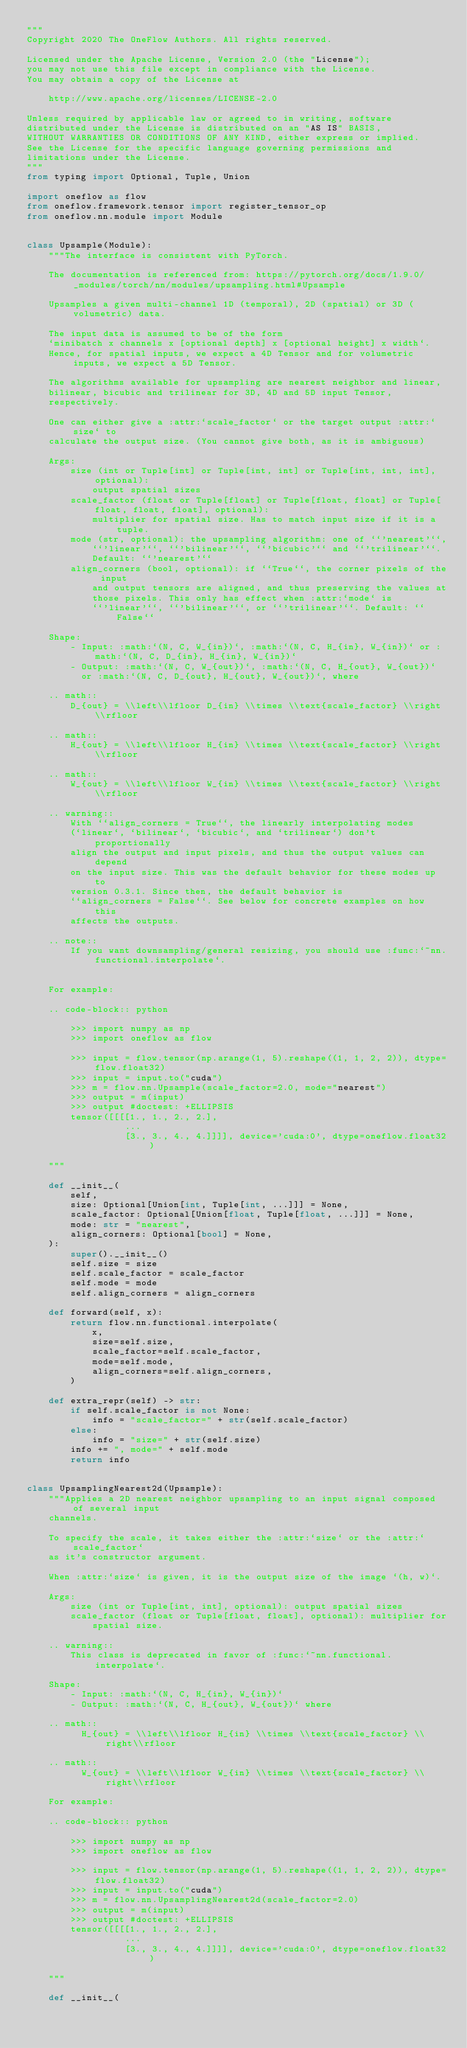Convert code to text. <code><loc_0><loc_0><loc_500><loc_500><_Python_>"""
Copyright 2020 The OneFlow Authors. All rights reserved.

Licensed under the Apache License, Version 2.0 (the "License");
you may not use this file except in compliance with the License.
You may obtain a copy of the License at

    http://www.apache.org/licenses/LICENSE-2.0

Unless required by applicable law or agreed to in writing, software
distributed under the License is distributed on an "AS IS" BASIS,
WITHOUT WARRANTIES OR CONDITIONS OF ANY KIND, either express or implied.
See the License for the specific language governing permissions and
limitations under the License.
"""
from typing import Optional, Tuple, Union

import oneflow as flow
from oneflow.framework.tensor import register_tensor_op
from oneflow.nn.module import Module


class Upsample(Module):
    """The interface is consistent with PyTorch.    
    
    The documentation is referenced from: https://pytorch.org/docs/1.9.0/_modules/torch/nn/modules/upsampling.html#Upsample
    
    Upsamples a given multi-channel 1D (temporal), 2D (spatial) or 3D (volumetric) data.

    The input data is assumed to be of the form
    `minibatch x channels x [optional depth] x [optional height] x width`.
    Hence, for spatial inputs, we expect a 4D Tensor and for volumetric inputs, we expect a 5D Tensor.

    The algorithms available for upsampling are nearest neighbor and linear,
    bilinear, bicubic and trilinear for 3D, 4D and 5D input Tensor,
    respectively.

    One can either give a :attr:`scale_factor` or the target output :attr:`size` to
    calculate the output size. (You cannot give both, as it is ambiguous)

    Args:
        size (int or Tuple[int] or Tuple[int, int] or Tuple[int, int, int], optional):
            output spatial sizes
        scale_factor (float or Tuple[float] or Tuple[float, float] or Tuple[float, float, float], optional):
            multiplier for spatial size. Has to match input size if it is a tuple.
        mode (str, optional): the upsampling algorithm: one of ``'nearest'``,
            ``'linear'``, ``'bilinear'``, ``'bicubic'`` and ``'trilinear'``.
            Default: ``'nearest'``
        align_corners (bool, optional): if ``True``, the corner pixels of the input
            and output tensors are aligned, and thus preserving the values at
            those pixels. This only has effect when :attr:`mode` is
            ``'linear'``, ``'bilinear'``, or ``'trilinear'``. Default: ``False``

    Shape:
        - Input: :math:`(N, C, W_{in})`, :math:`(N, C, H_{in}, W_{in})` or :math:`(N, C, D_{in}, H_{in}, W_{in})`
        - Output: :math:`(N, C, W_{out})`, :math:`(N, C, H_{out}, W_{out})`
          or :math:`(N, C, D_{out}, H_{out}, W_{out})`, where

    .. math::
        D_{out} = \\left\\lfloor D_{in} \\times \\text{scale_factor} \\right\\rfloor

    .. math::
        H_{out} = \\left\\lfloor H_{in} \\times \\text{scale_factor} \\right\\rfloor

    .. math::
        W_{out} = \\left\\lfloor W_{in} \\times \\text{scale_factor} \\right\\rfloor

    .. warning::
        With ``align_corners = True``, the linearly interpolating modes
        (`linear`, `bilinear`, `bicubic`, and `trilinear`) don't proportionally
        align the output and input pixels, and thus the output values can depend
        on the input size. This was the default behavior for these modes up to
        version 0.3.1. Since then, the default behavior is
        ``align_corners = False``. See below for concrete examples on how this
        affects the outputs.

    .. note::
        If you want downsampling/general resizing, you should use :func:`~nn.functional.interpolate`.


    For example:

    .. code-block:: python

        >>> import numpy as np
        >>> import oneflow as flow

        >>> input = flow.tensor(np.arange(1, 5).reshape((1, 1, 2, 2)), dtype=flow.float32)
        >>> input = input.to("cuda")
        >>> m = flow.nn.Upsample(scale_factor=2.0, mode="nearest")
        >>> output = m(input)
        >>> output #doctest: +ELLIPSIS
        tensor([[[[1., 1., 2., 2.],
                  ...
                  [3., 3., 4., 4.]]]], device='cuda:0', dtype=oneflow.float32)

    """

    def __init__(
        self,
        size: Optional[Union[int, Tuple[int, ...]]] = None,
        scale_factor: Optional[Union[float, Tuple[float, ...]]] = None,
        mode: str = "nearest",
        align_corners: Optional[bool] = None,
    ):
        super().__init__()
        self.size = size
        self.scale_factor = scale_factor
        self.mode = mode
        self.align_corners = align_corners

    def forward(self, x):
        return flow.nn.functional.interpolate(
            x,
            size=self.size,
            scale_factor=self.scale_factor,
            mode=self.mode,
            align_corners=self.align_corners,
        )

    def extra_repr(self) -> str:
        if self.scale_factor is not None:
            info = "scale_factor=" + str(self.scale_factor)
        else:
            info = "size=" + str(self.size)
        info += ", mode=" + self.mode
        return info


class UpsamplingNearest2d(Upsample):
    """Applies a 2D nearest neighbor upsampling to an input signal composed of several input
    channels.

    To specify the scale, it takes either the :attr:`size` or the :attr:`scale_factor`
    as it's constructor argument.

    When :attr:`size` is given, it is the output size of the image `(h, w)`.

    Args:
        size (int or Tuple[int, int], optional): output spatial sizes
        scale_factor (float or Tuple[float, float], optional): multiplier for
            spatial size.

    .. warning::
        This class is deprecated in favor of :func:`~nn.functional.interpolate`.

    Shape:
        - Input: :math:`(N, C, H_{in}, W_{in})`
        - Output: :math:`(N, C, H_{out}, W_{out})` where

    .. math::
          H_{out} = \\left\\lfloor H_{in} \\times \\text{scale_factor} \\right\\rfloor

    .. math::
          W_{out} = \\left\\lfloor W_{in} \\times \\text{scale_factor} \\right\\rfloor

    For example:

    .. code-block:: python

        >>> import numpy as np
        >>> import oneflow as flow
        
        >>> input = flow.tensor(np.arange(1, 5).reshape((1, 1, 2, 2)), dtype=flow.float32)
        >>> input = input.to("cuda")
        >>> m = flow.nn.UpsamplingNearest2d(scale_factor=2.0)
        >>> output = m(input)
        >>> output #doctest: +ELLIPSIS
        tensor([[[[1., 1., 2., 2.],
                  ...
                  [3., 3., 4., 4.]]]], device='cuda:0', dtype=oneflow.float32)

    """

    def __init__(</code> 